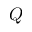Convert formula to latex. <formula><loc_0><loc_0><loc_500><loc_500>Q</formula> 